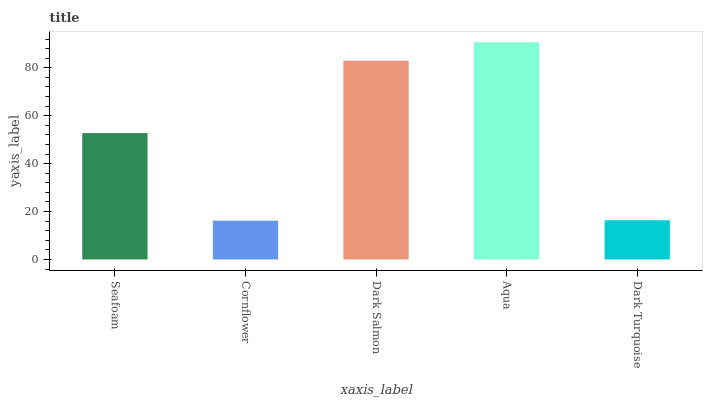Is Aqua the maximum?
Answer yes or no. Yes. Is Dark Salmon the minimum?
Answer yes or no. No. Is Dark Salmon the maximum?
Answer yes or no. No. Is Dark Salmon greater than Cornflower?
Answer yes or no. Yes. Is Cornflower less than Dark Salmon?
Answer yes or no. Yes. Is Cornflower greater than Dark Salmon?
Answer yes or no. No. Is Dark Salmon less than Cornflower?
Answer yes or no. No. Is Seafoam the high median?
Answer yes or no. Yes. Is Seafoam the low median?
Answer yes or no. Yes. Is Aqua the high median?
Answer yes or no. No. Is Aqua the low median?
Answer yes or no. No. 